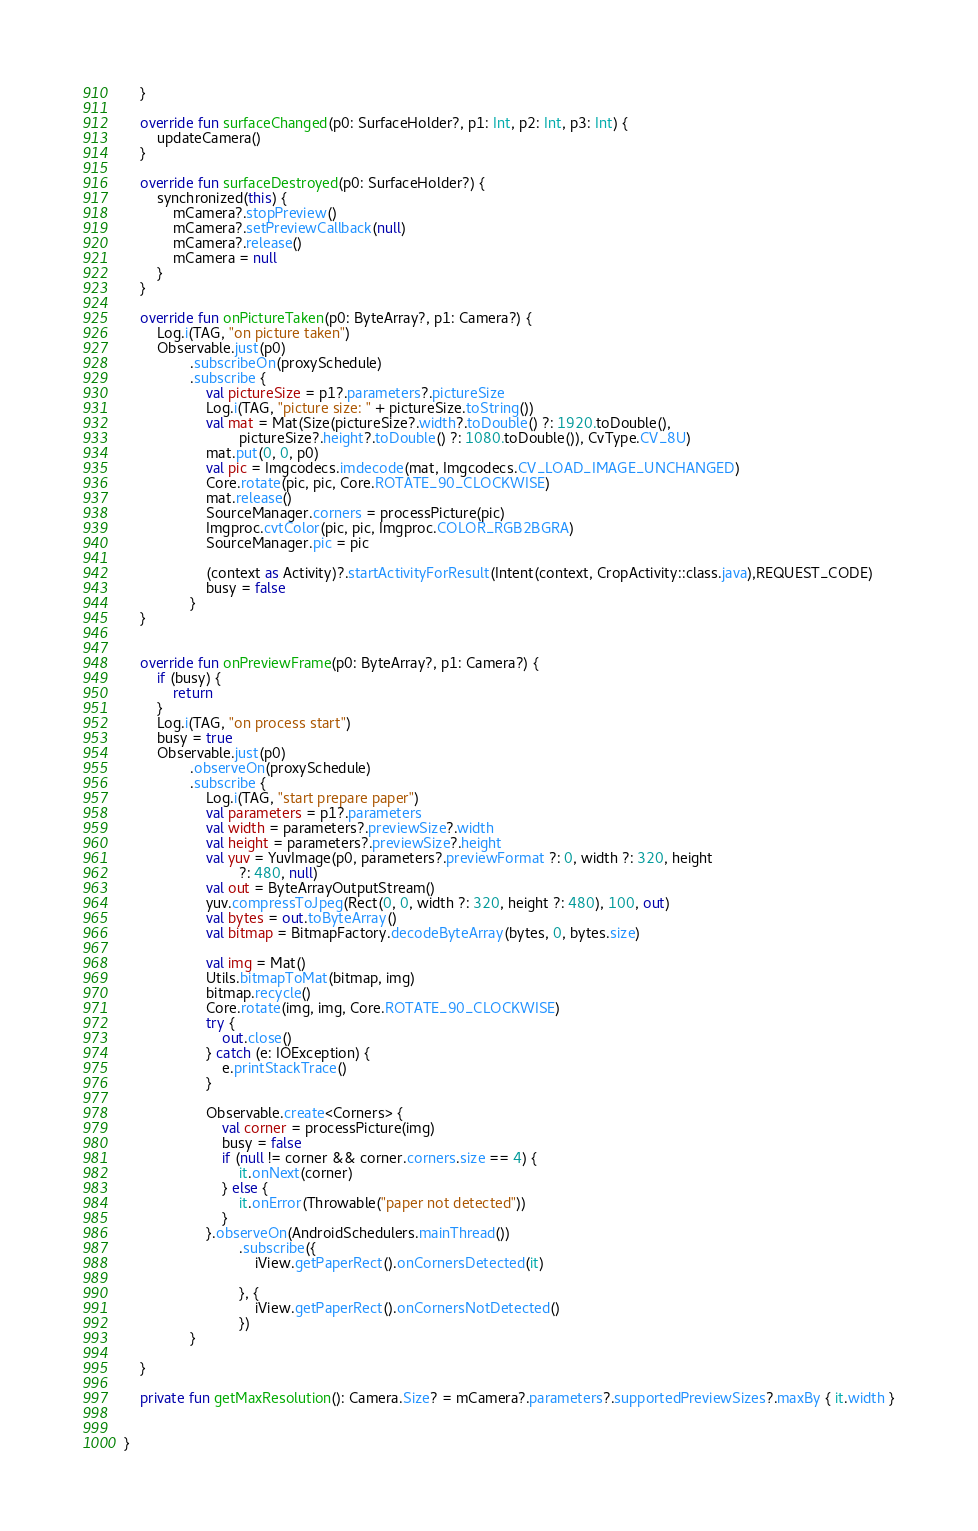Convert code to text. <code><loc_0><loc_0><loc_500><loc_500><_Kotlin_>    }

    override fun surfaceChanged(p0: SurfaceHolder?, p1: Int, p2: Int, p3: Int) {
        updateCamera()
    }

    override fun surfaceDestroyed(p0: SurfaceHolder?) {
        synchronized(this) {
            mCamera?.stopPreview()
            mCamera?.setPreviewCallback(null)
            mCamera?.release()
            mCamera = null
        }
    }

    override fun onPictureTaken(p0: ByteArray?, p1: Camera?) {
        Log.i(TAG, "on picture taken")
        Observable.just(p0)
                .subscribeOn(proxySchedule)
                .subscribe {
                    val pictureSize = p1?.parameters?.pictureSize
                    Log.i(TAG, "picture size: " + pictureSize.toString())
                    val mat = Mat(Size(pictureSize?.width?.toDouble() ?: 1920.toDouble(),
                            pictureSize?.height?.toDouble() ?: 1080.toDouble()), CvType.CV_8U)
                    mat.put(0, 0, p0)
                    val pic = Imgcodecs.imdecode(mat, Imgcodecs.CV_LOAD_IMAGE_UNCHANGED)
                    Core.rotate(pic, pic, Core.ROTATE_90_CLOCKWISE)
                    mat.release()
                    SourceManager.corners = processPicture(pic)
                    Imgproc.cvtColor(pic, pic, Imgproc.COLOR_RGB2BGRA)
                    SourceManager.pic = pic

                    (context as Activity)?.startActivityForResult(Intent(context, CropActivity::class.java),REQUEST_CODE)
                    busy = false
                }
    }


    override fun onPreviewFrame(p0: ByteArray?, p1: Camera?) {
        if (busy) {
            return
        }
        Log.i(TAG, "on process start")
        busy = true
        Observable.just(p0)
                .observeOn(proxySchedule)
                .subscribe {
                    Log.i(TAG, "start prepare paper")
                    val parameters = p1?.parameters
                    val width = parameters?.previewSize?.width
                    val height = parameters?.previewSize?.height
                    val yuv = YuvImage(p0, parameters?.previewFormat ?: 0, width ?: 320, height
                            ?: 480, null)
                    val out = ByteArrayOutputStream()
                    yuv.compressToJpeg(Rect(0, 0, width ?: 320, height ?: 480), 100, out)
                    val bytes = out.toByteArray()
                    val bitmap = BitmapFactory.decodeByteArray(bytes, 0, bytes.size)

                    val img = Mat()
                    Utils.bitmapToMat(bitmap, img)
                    bitmap.recycle()
                    Core.rotate(img, img, Core.ROTATE_90_CLOCKWISE)
                    try {
                        out.close()
                    } catch (e: IOException) {
                        e.printStackTrace()
                    }

                    Observable.create<Corners> {
                        val corner = processPicture(img)
                        busy = false
                        if (null != corner && corner.corners.size == 4) {
                            it.onNext(corner)
                        } else {
                            it.onError(Throwable("paper not detected"))
                        }
                    }.observeOn(AndroidSchedulers.mainThread())
                            .subscribe({
                                iView.getPaperRect().onCornersDetected(it)

                            }, {
                                iView.getPaperRect().onCornersNotDetected()
                            })
                }

    }

    private fun getMaxResolution(): Camera.Size? = mCamera?.parameters?.supportedPreviewSizes?.maxBy { it.width }


}</code> 